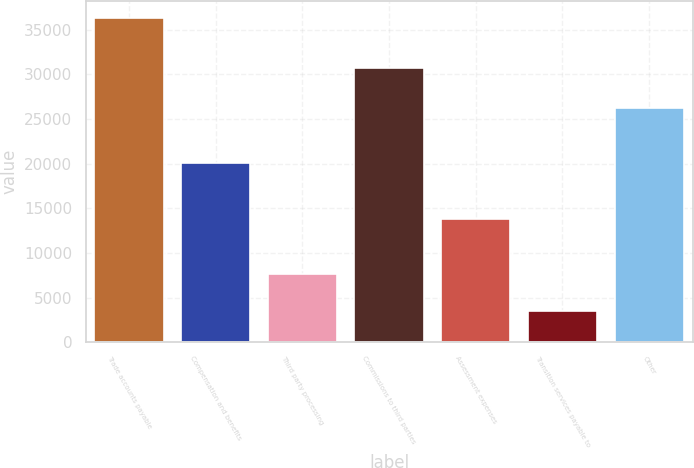Convert chart to OTSL. <chart><loc_0><loc_0><loc_500><loc_500><bar_chart><fcel>Trade accounts payable<fcel>Compensation and benefits<fcel>Third party processing<fcel>Commissions to third parties<fcel>Assessment expenses<fcel>Transition services payable to<fcel>Other<nl><fcel>36347<fcel>20041<fcel>7624<fcel>30699<fcel>13801<fcel>3534<fcel>26197<nl></chart> 